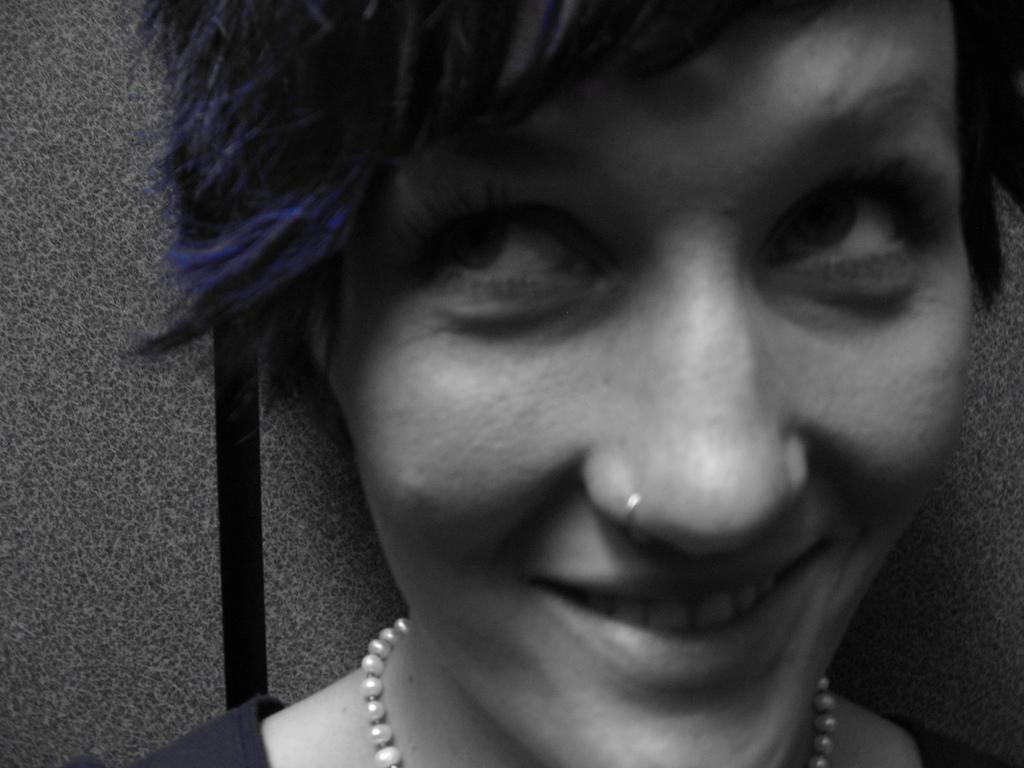What is the main subject in the foreground of the image? There is a person in the foreground of the image. What accessories is the person wearing? The person is wearing a pearl necklace and a nose ring. What is the facial expression of the person in the image? The person is smiling. What can be seen in the background of the image? There is an object in the background that appears to be a wall. Can you see any feathers on the person's clothing in the image? There are no feathers visible on the person's clothing in the image. Is there a railway track visible in the image? There is no railway track present in the image. 